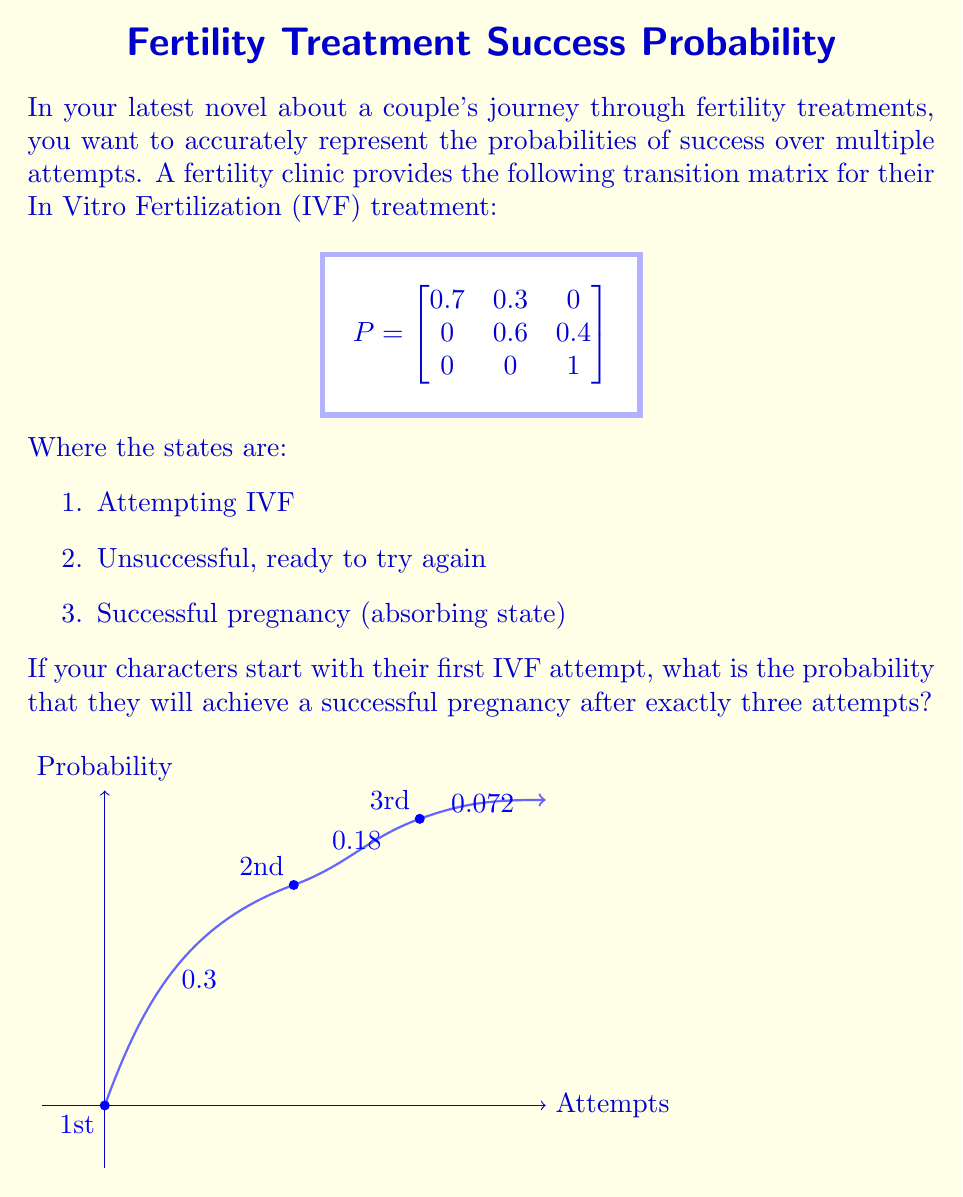What is the answer to this math problem? To solve this problem, we'll use the properties of transition matrices and matrix multiplication. Let's break it down step-by-step:

1) First, we need to calculate $P^3$, which represents the transition probabilities after three steps (attempts):

   $$P^3 = P \times P \times P$$

2) We can calculate this using matrix multiplication:

   $$
   P^3 = \begin{bmatrix}
   0.343 & 0.441 & 0.216 \\
   0 & 0.216 & 0.784 \\
   0 & 0 & 1
   \end{bmatrix}
   $$

3) The probability we're looking for is the entry in the first row, third column of $P^3$. This represents the probability of moving from state 1 (first attempt) to state 3 (successful pregnancy) in exactly three steps.

4) From the matrix $P^3$, we can see that this probability is 0.216 or 21.6%.

5) We can also calculate this probability step-by-step:
   - Probability of failing first attempt: 0.3
   - Probability of failing second attempt after failing first: 0.3 * 0.6 = 0.18
   - Probability of succeeding on third attempt after failing first two: 0.3 * 0.6 * 0.4 = 0.072

   The sum of these probabilities (0.3 + 0.18 + 0.072 = 0.552) represents all paths to state 3, but we only want the last one for exactly three attempts.

This analysis provides a realistic representation of the cumulative chances of success over multiple IVF attempts, which could add depth and accuracy to your novel's portrayal of the fertility treatment journey.
Answer: 0.216 or 21.6% 